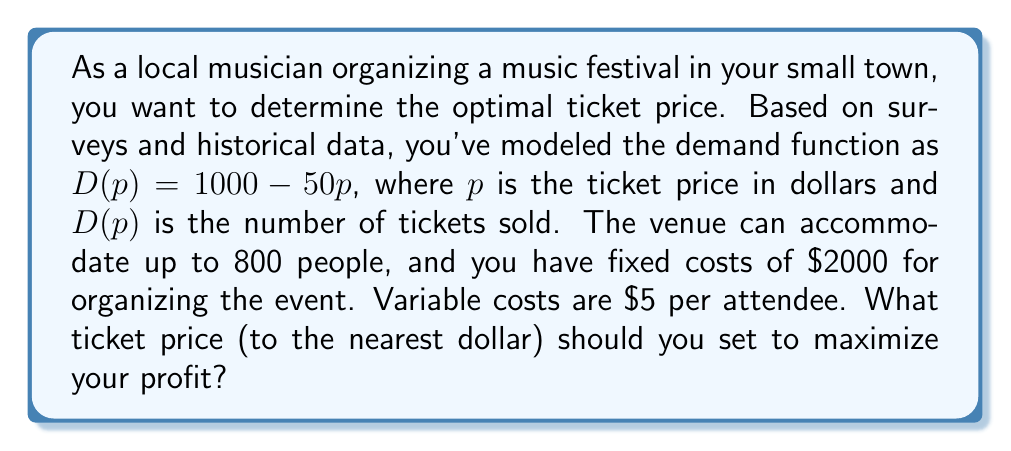Can you solve this math problem? Let's approach this step-by-step:

1) First, we need to set up our profit function. Profit is revenue minus costs.

2) Revenue is price times quantity: $R = pD(p) = p(1000 - 50p)$

3) Costs are fixed costs plus variable costs times quantity:
   $C = 2000 + 5D(p) = 2000 + 5(1000 - 50p)$

4) So our profit function is:
   $$\Pi(p) = R - C = p(1000 - 50p) - [2000 + 5(1000 - 50p)]$$

5) Simplify:
   $$\Pi(p) = 1000p - 50p^2 - 2000 - 5000 + 250p$$
   $$\Pi(p) = 1250p - 50p^2 - 7000$$

6) To find the maximum profit, we differentiate and set to zero:
   $$\frac{d\Pi}{dp} = 1250 - 100p = 0$$

7) Solve:
   $$100p = 1250$$
   $$p = 12.50$$

8) The second derivative is negative ($-100$), confirming this is a maximum.

9) However, we need to check if this satisfies our capacity constraint:
   $D(12.50) = 1000 - 50(12.50) = 375$
   This is less than 800, so it's feasible.

10) Rounding to the nearest dollar gives us $13.
Answer: $13 